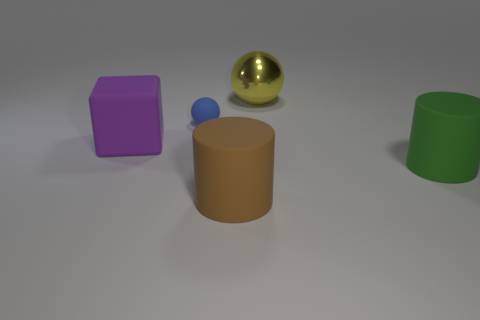Add 5 big gray things. How many objects exist? 10 Subtract all balls. How many objects are left? 3 Subtract all cylinders. Subtract all big metallic spheres. How many objects are left? 2 Add 1 large green cylinders. How many large green cylinders are left? 2 Add 1 yellow spheres. How many yellow spheres exist? 2 Subtract 0 green blocks. How many objects are left? 5 